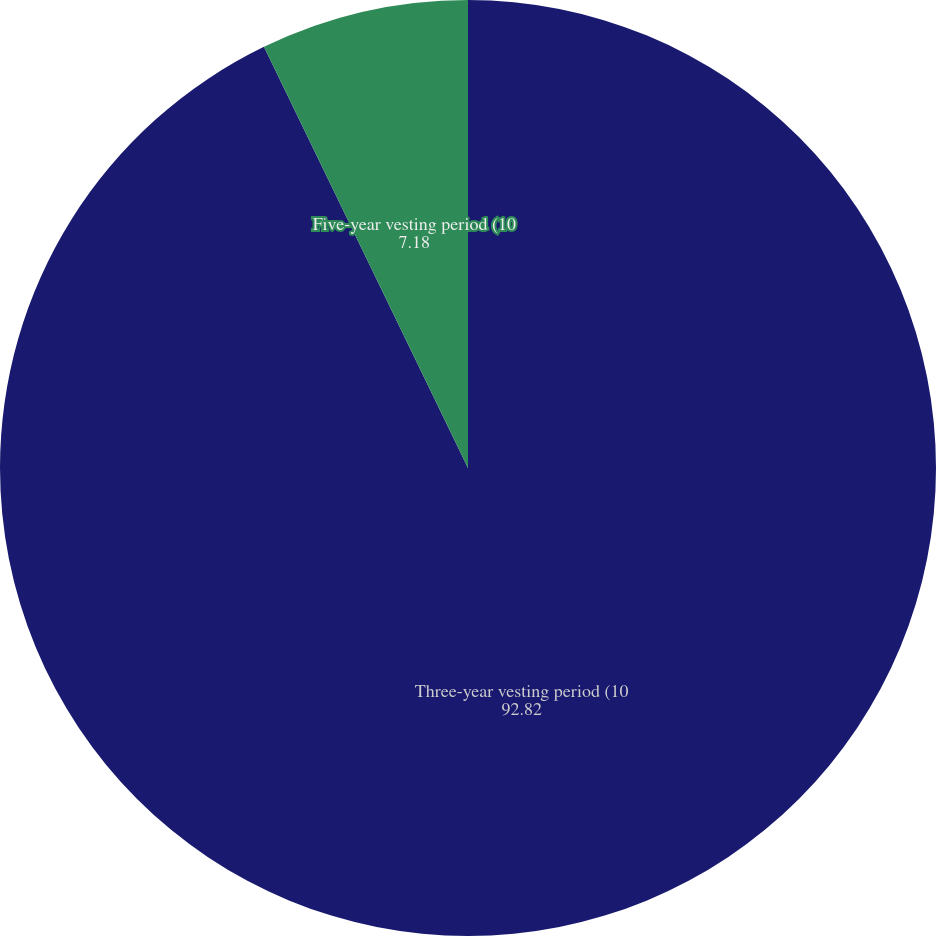<chart> <loc_0><loc_0><loc_500><loc_500><pie_chart><fcel>Three-year vesting period (10<fcel>Five-year vesting period (10<nl><fcel>92.82%<fcel>7.18%<nl></chart> 